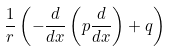Convert formula to latex. <formula><loc_0><loc_0><loc_500><loc_500>\frac { 1 } { r } \left ( - \frac { d } { d x } \left ( p \frac { d } { d x } \right ) + q \right )</formula> 